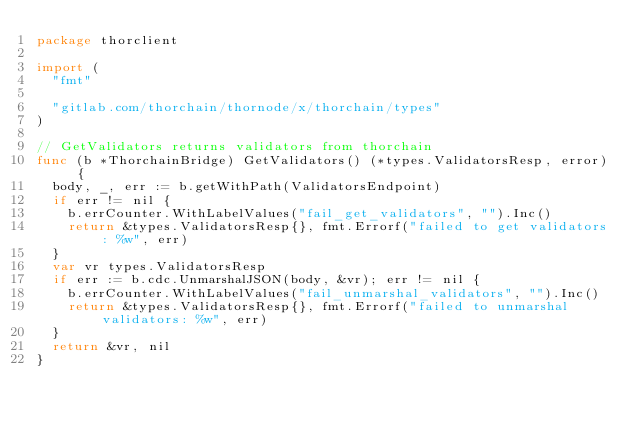<code> <loc_0><loc_0><loc_500><loc_500><_Go_>package thorclient

import (
	"fmt"

	"gitlab.com/thorchain/thornode/x/thorchain/types"
)

// GetValidators returns validators from thorchain
func (b *ThorchainBridge) GetValidators() (*types.ValidatorsResp, error) {
	body, _, err := b.getWithPath(ValidatorsEndpoint)
	if err != nil {
		b.errCounter.WithLabelValues("fail_get_validators", "").Inc()
		return &types.ValidatorsResp{}, fmt.Errorf("failed to get validators: %w", err)
	}
	var vr types.ValidatorsResp
	if err := b.cdc.UnmarshalJSON(body, &vr); err != nil {
		b.errCounter.WithLabelValues("fail_unmarshal_validators", "").Inc()
		return &types.ValidatorsResp{}, fmt.Errorf("failed to unmarshal validators: %w", err)
	}
	return &vr, nil
}
</code> 